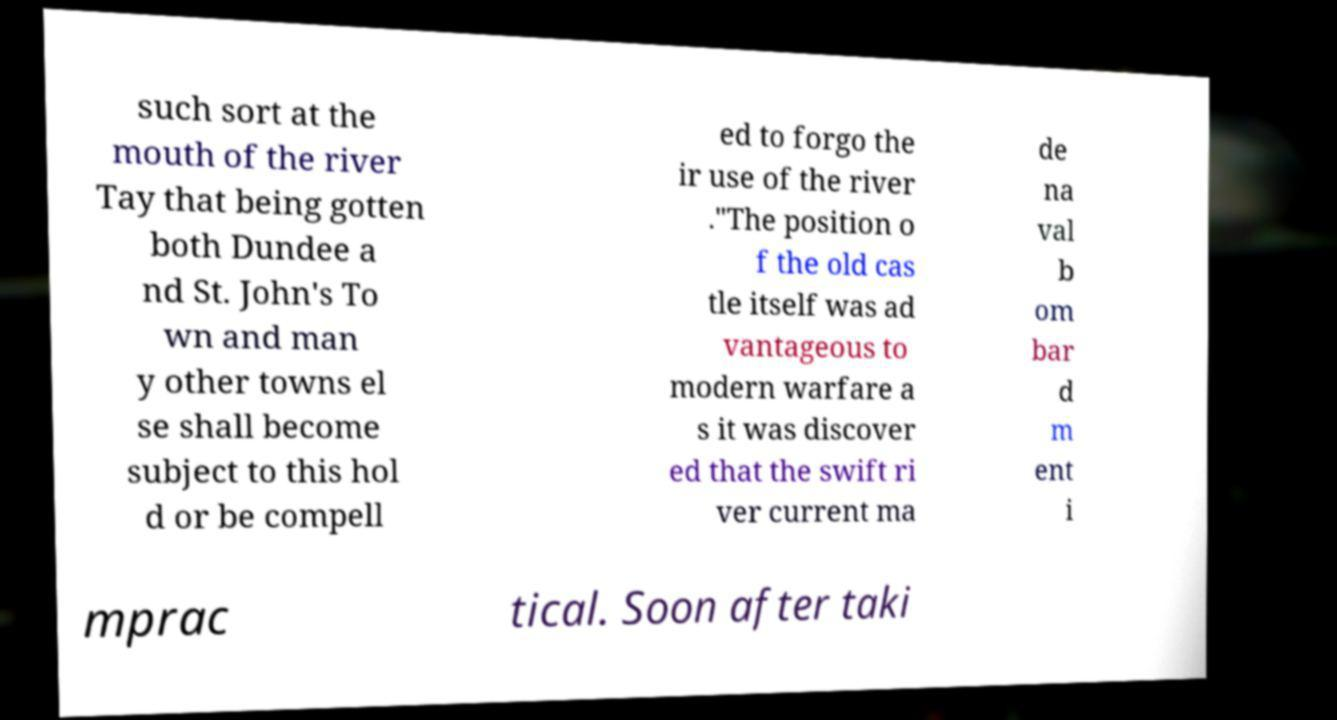There's text embedded in this image that I need extracted. Can you transcribe it verbatim? such sort at the mouth of the river Tay that being gotten both Dundee a nd St. John's To wn and man y other towns el se shall become subject to this hol d or be compell ed to forgo the ir use of the river ."The position o f the old cas tle itself was ad vantageous to modern warfare a s it was discover ed that the swift ri ver current ma de na val b om bar d m ent i mprac tical. Soon after taki 